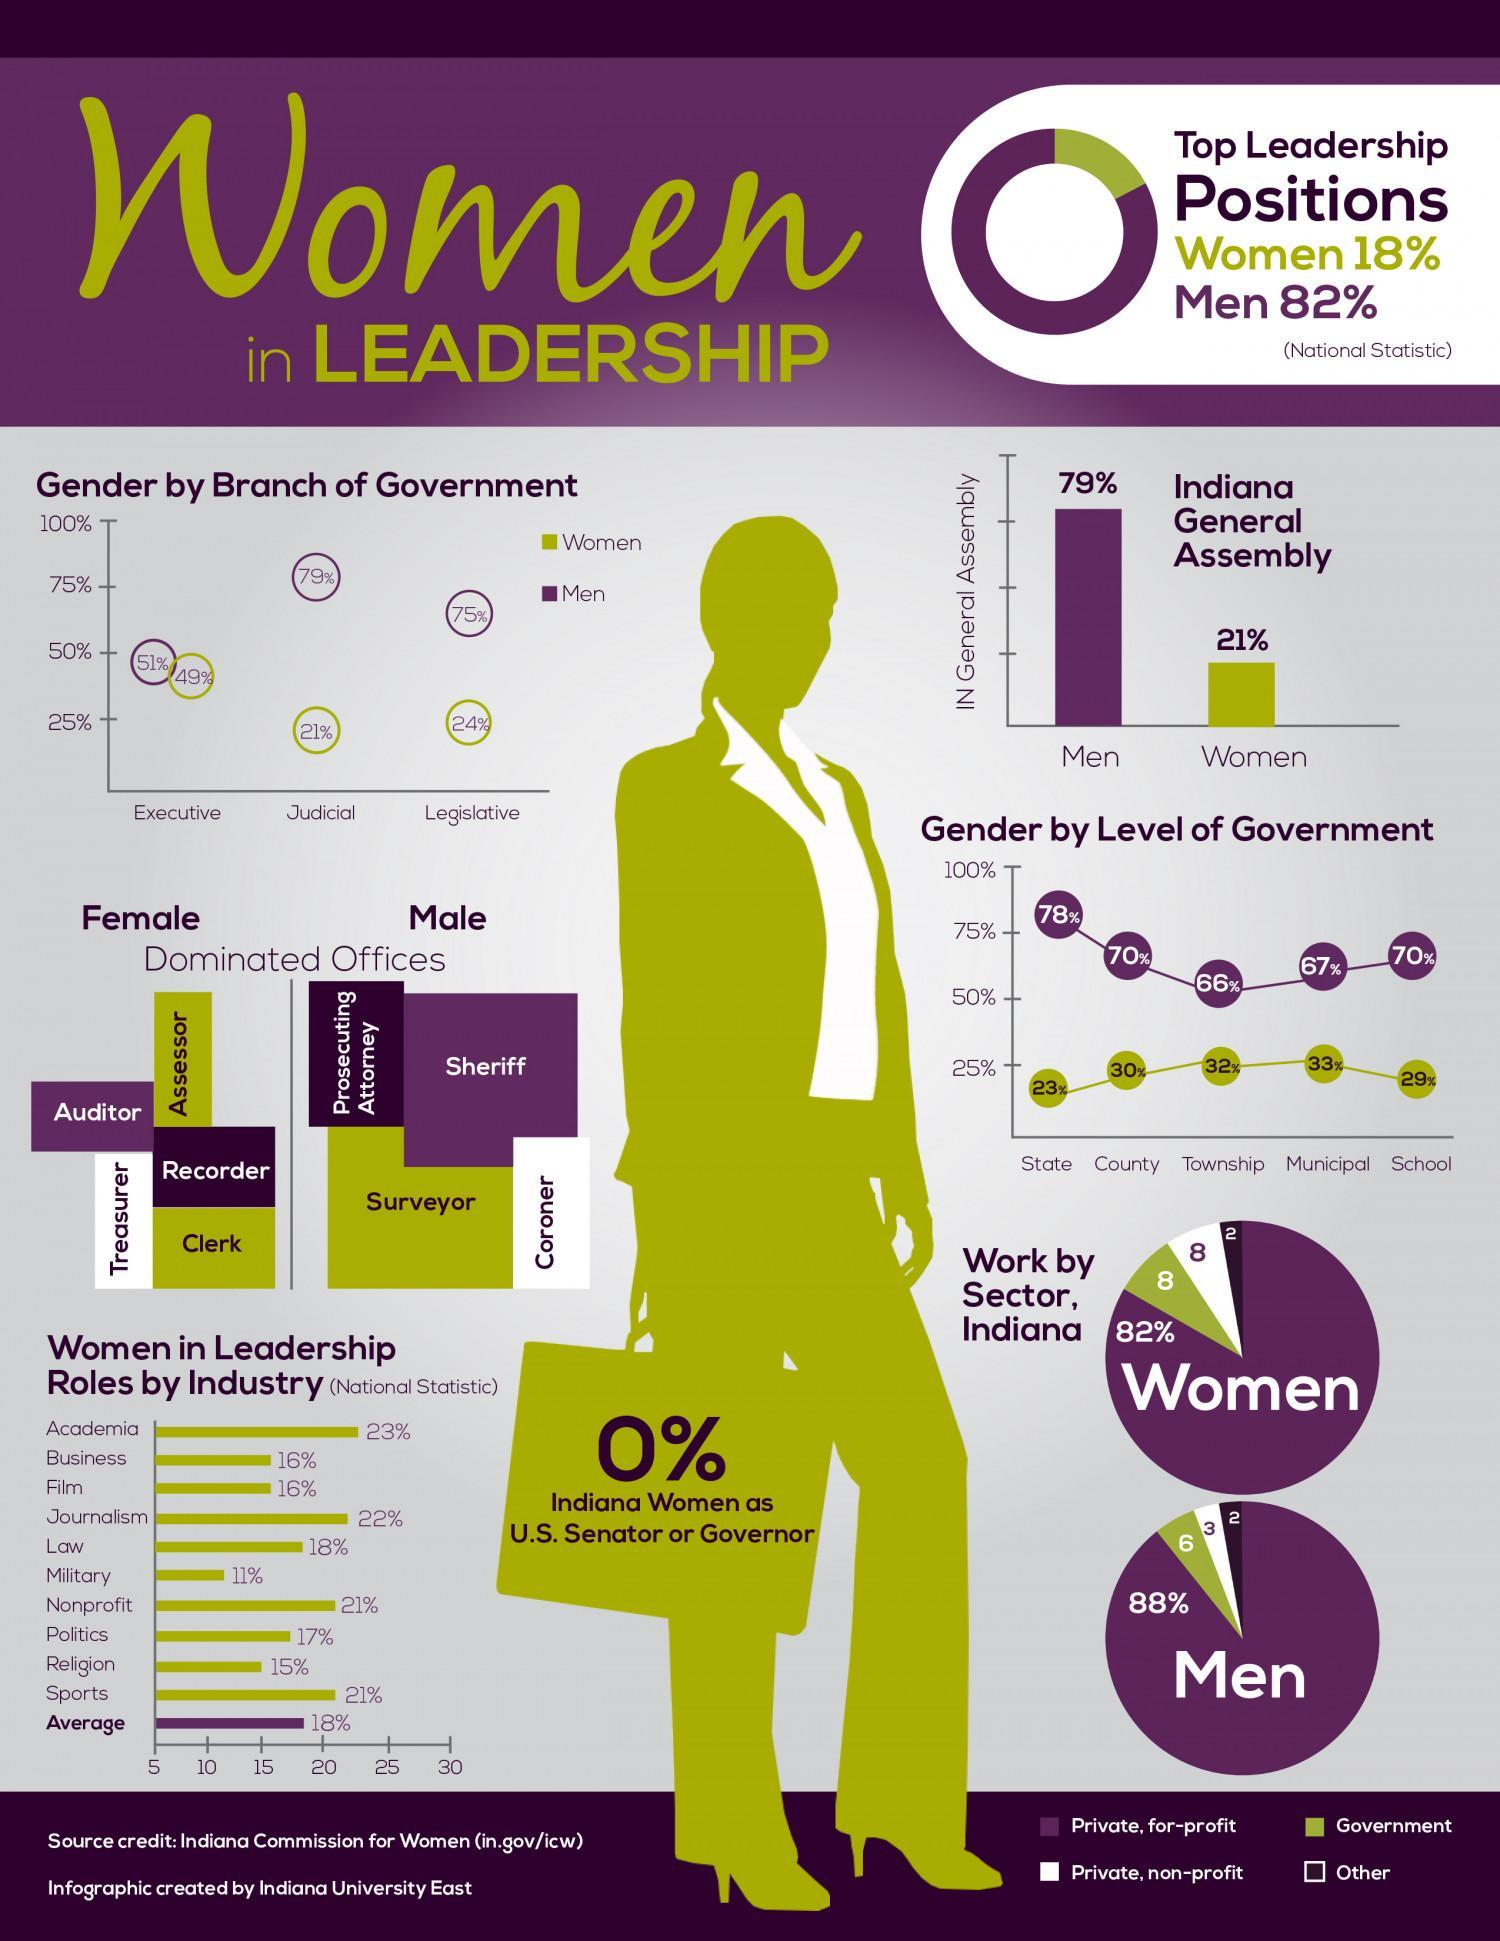What is the percentage of men in the executive and judicial branches of government?
Answer the question with a short phrase. 130% What is the percentage of women in a leadership role in the sports and religion sector, taken together? 36% What is the percentage of women in the executive and judicial branches of government? 70% What is the percentage of men in the legislative and judicial branches of government? 154% What is the percentage of women in the legislative and judicial branches of government? 45% What is the number of female-dominated offices? 5 What is the percentage of women in a leadership role in the law and military sector, taken together? 29% What is the number of male-dominated offices? 4 What is the percentage of women in a leadership role in the business and film sector, taken together? 32% 